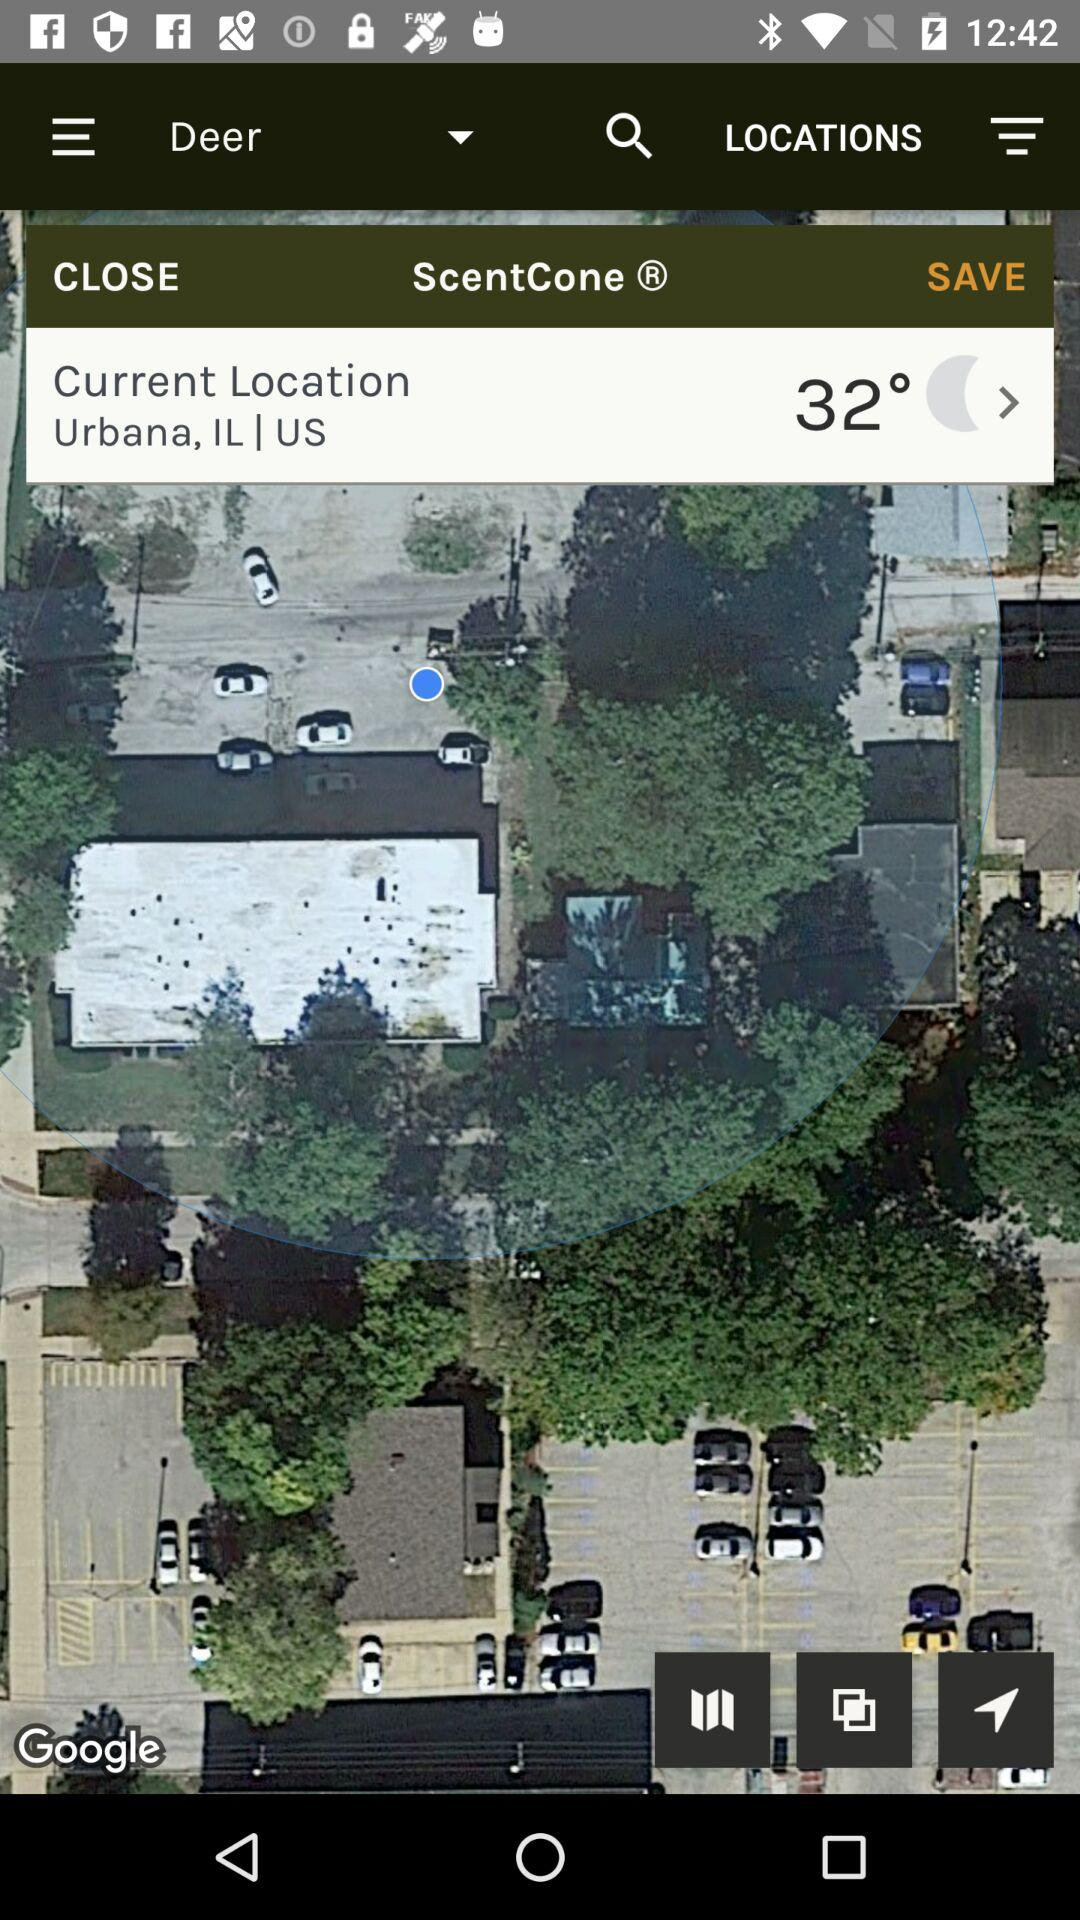What is the temperature? The temperature is 32°. 